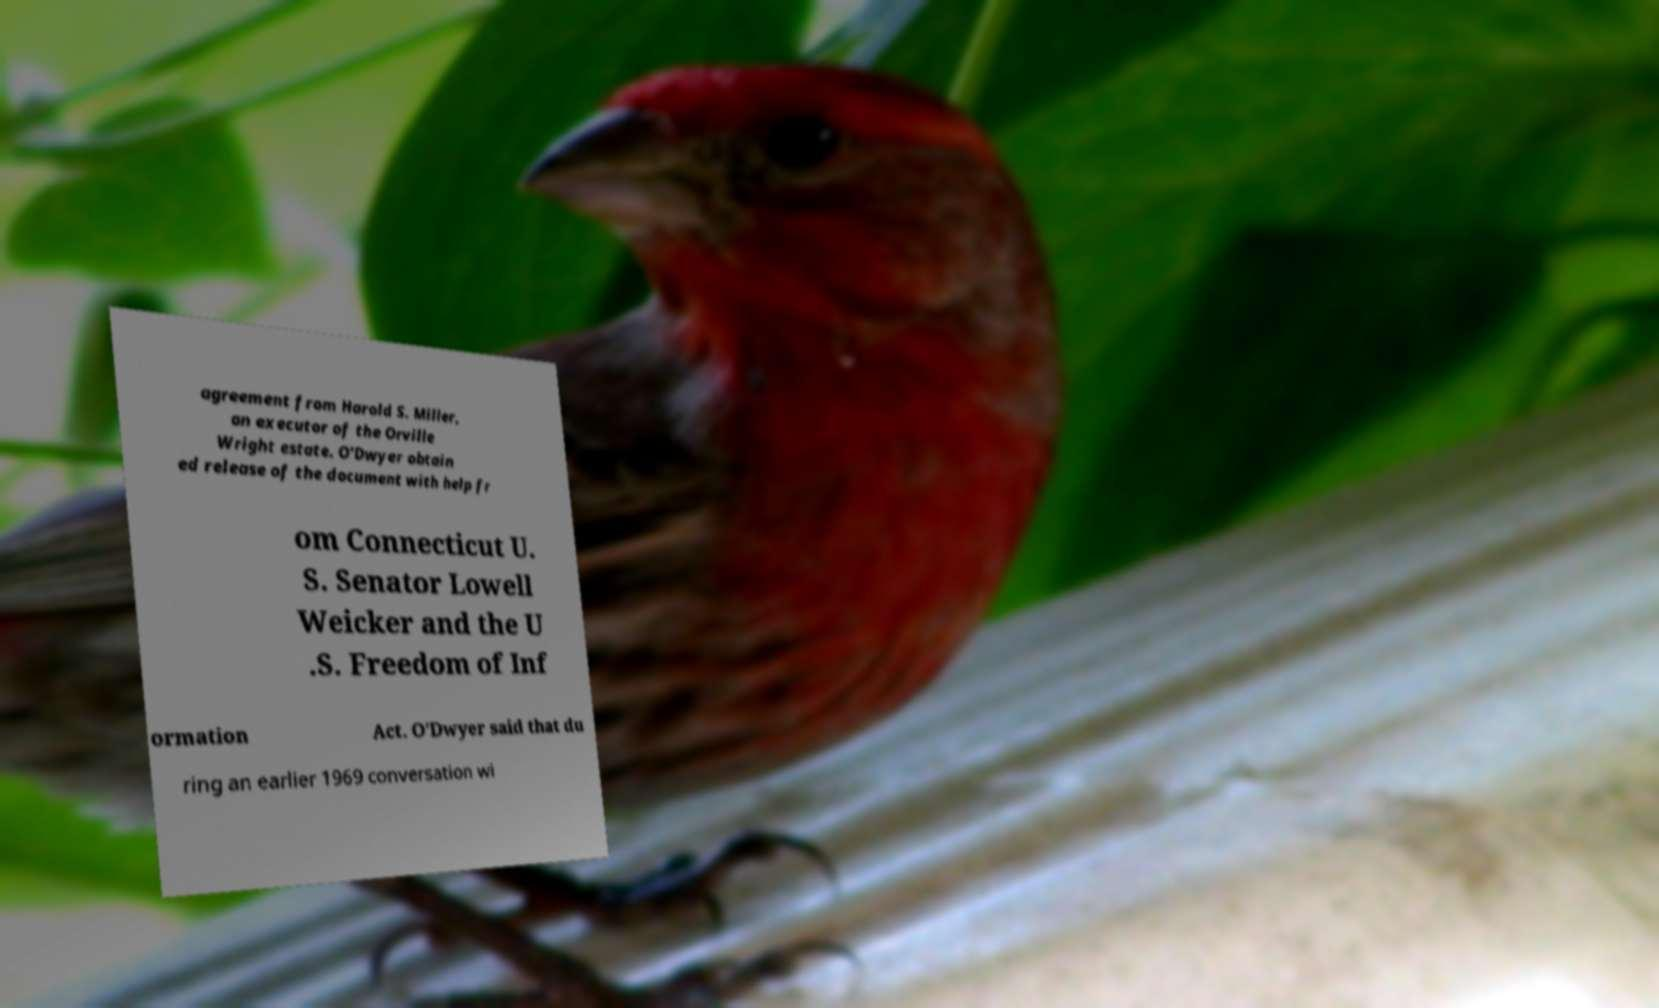Could you extract and type out the text from this image? agreement from Harold S. Miller, an executor of the Orville Wright estate. O'Dwyer obtain ed release of the document with help fr om Connecticut U. S. Senator Lowell Weicker and the U .S. Freedom of Inf ormation Act. O'Dwyer said that du ring an earlier 1969 conversation wi 